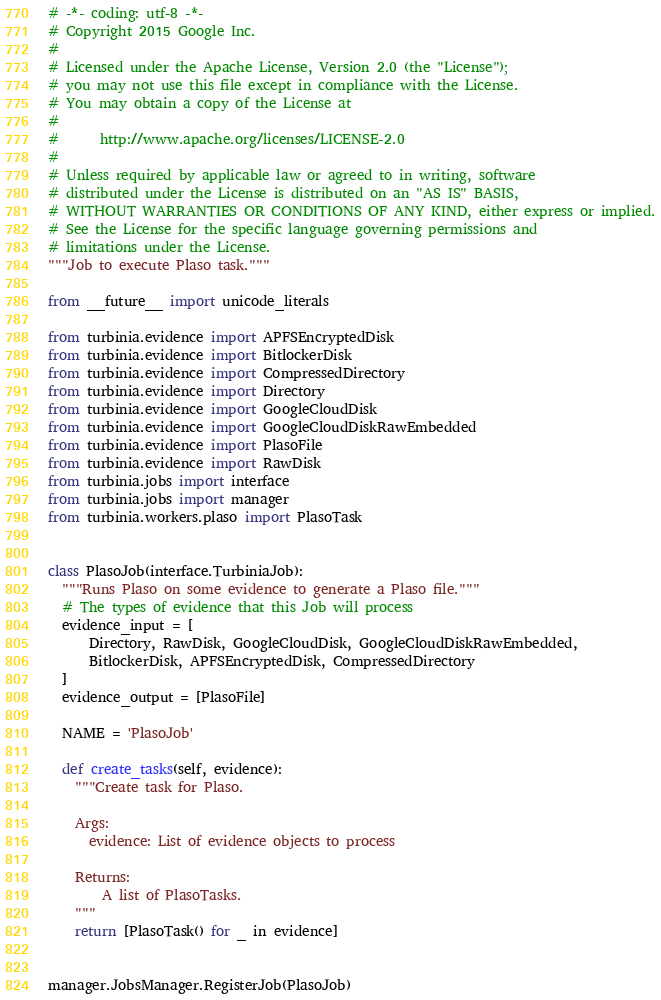Convert code to text. <code><loc_0><loc_0><loc_500><loc_500><_Python_># -*- coding: utf-8 -*-
# Copyright 2015 Google Inc.
#
# Licensed under the Apache License, Version 2.0 (the "License");
# you may not use this file except in compliance with the License.
# You may obtain a copy of the License at
#
#      http://www.apache.org/licenses/LICENSE-2.0
#
# Unless required by applicable law or agreed to in writing, software
# distributed under the License is distributed on an "AS IS" BASIS,
# WITHOUT WARRANTIES OR CONDITIONS OF ANY KIND, either express or implied.
# See the License for the specific language governing permissions and
# limitations under the License.
"""Job to execute Plaso task."""

from __future__ import unicode_literals

from turbinia.evidence import APFSEncryptedDisk
from turbinia.evidence import BitlockerDisk
from turbinia.evidence import CompressedDirectory
from turbinia.evidence import Directory
from turbinia.evidence import GoogleCloudDisk
from turbinia.evidence import GoogleCloudDiskRawEmbedded
from turbinia.evidence import PlasoFile
from turbinia.evidence import RawDisk
from turbinia.jobs import interface
from turbinia.jobs import manager
from turbinia.workers.plaso import PlasoTask


class PlasoJob(interface.TurbiniaJob):
  """Runs Plaso on some evidence to generate a Plaso file."""
  # The types of evidence that this Job will process
  evidence_input = [
      Directory, RawDisk, GoogleCloudDisk, GoogleCloudDiskRawEmbedded,
      BitlockerDisk, APFSEncryptedDisk, CompressedDirectory
  ]
  evidence_output = [PlasoFile]

  NAME = 'PlasoJob'

  def create_tasks(self, evidence):
    """Create task for Plaso.

    Args:
      evidence: List of evidence objects to process

    Returns:
        A list of PlasoTasks.
    """
    return [PlasoTask() for _ in evidence]


manager.JobsManager.RegisterJob(PlasoJob)
</code> 